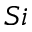<formula> <loc_0><loc_0><loc_500><loc_500>S i</formula> 